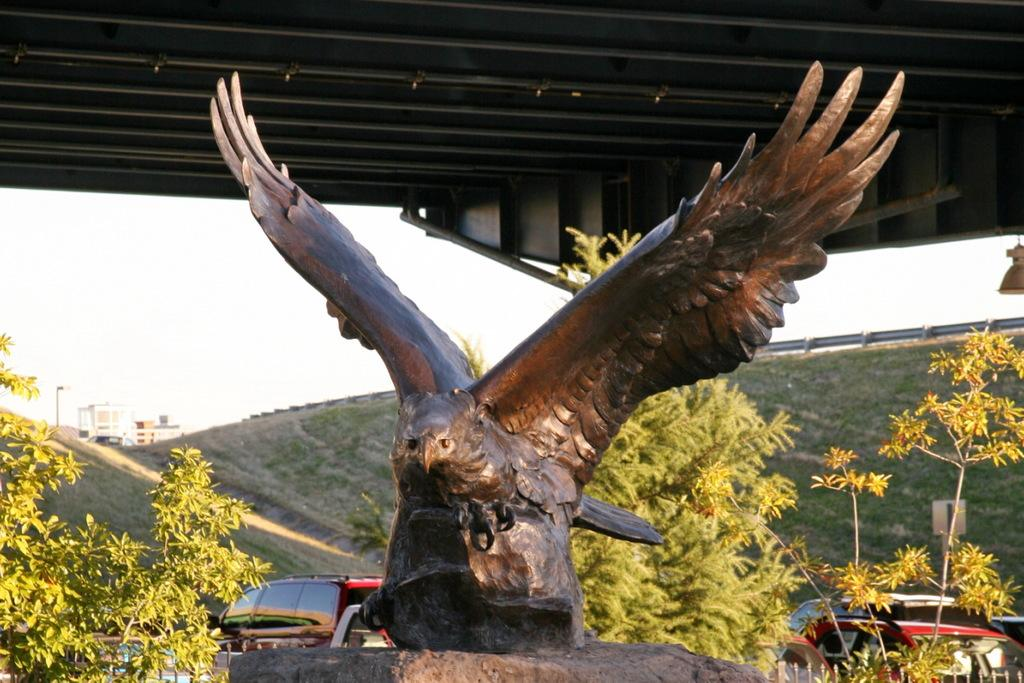What is located under the shed in the image? There is a statue under the shed in the image. What can be seen in the background of the image? There are trees, grass, buildings, a light pole, vehicles, and a board visible in the background of the image. What part of the natural environment is visible in the image? The sky is visible in the background of the image. What language is the statue speaking in the image? The statue is not speaking in the image, as it is an inanimate object. Can you hear the sound of the linen rustling in the image? There is no linen present in the image, so it is not possible to hear it rustling. 